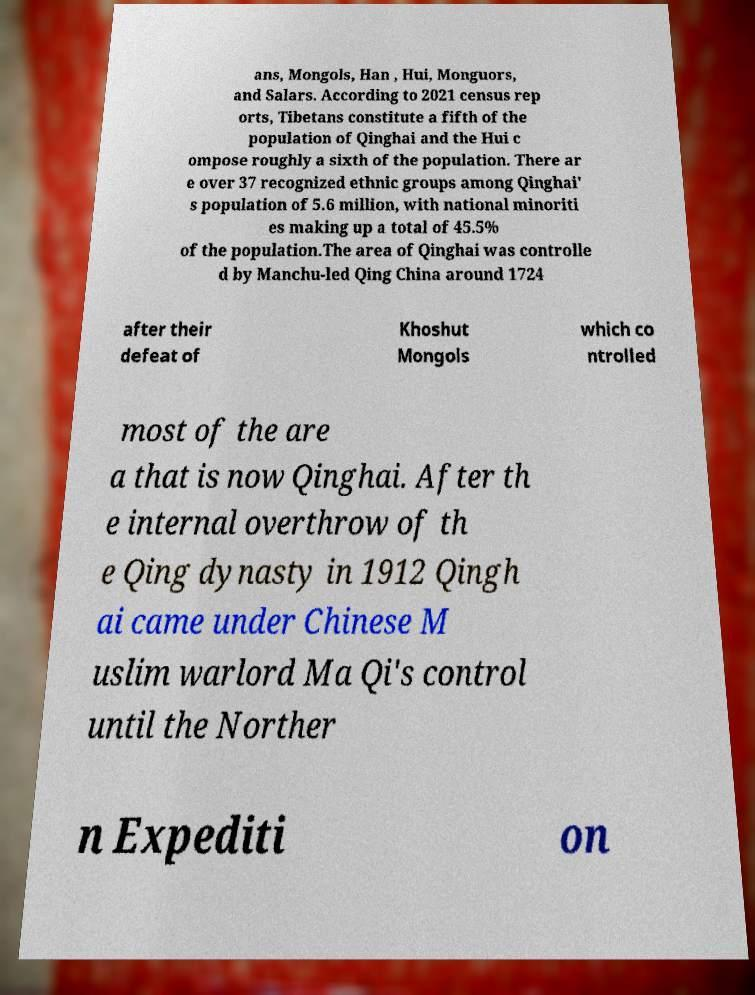Could you extract and type out the text from this image? ans, Mongols, Han , Hui, Monguors, and Salars. According to 2021 census rep orts, Tibetans constitute a fifth of the population of Qinghai and the Hui c ompose roughly a sixth of the population. There ar e over 37 recognized ethnic groups among Qinghai' s population of 5.6 million, with national minoriti es making up a total of 45.5% of the population.The area of Qinghai was controlle d by Manchu-led Qing China around 1724 after their defeat of Khoshut Mongols which co ntrolled most of the are a that is now Qinghai. After th e internal overthrow of th e Qing dynasty in 1912 Qingh ai came under Chinese M uslim warlord Ma Qi's control until the Norther n Expediti on 